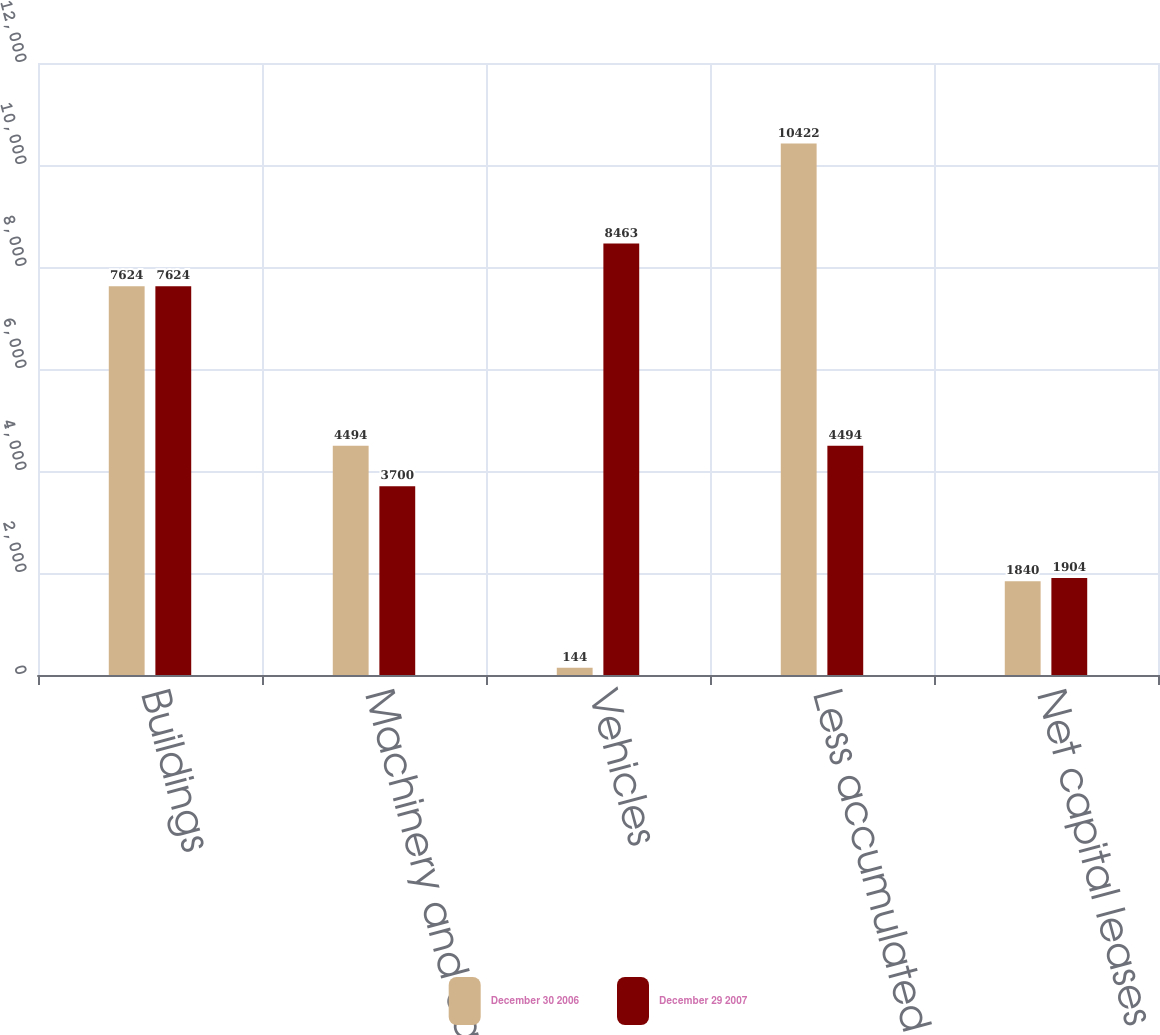Convert chart. <chart><loc_0><loc_0><loc_500><loc_500><stacked_bar_chart><ecel><fcel>Buildings<fcel>Machinery and equipment<fcel>Vehicles<fcel>Less accumulated depreciation<fcel>Net capital leases<nl><fcel>December 30 2006<fcel>7624<fcel>4494<fcel>144<fcel>10422<fcel>1840<nl><fcel>December 29 2007<fcel>7624<fcel>3700<fcel>8463<fcel>4494<fcel>1904<nl></chart> 